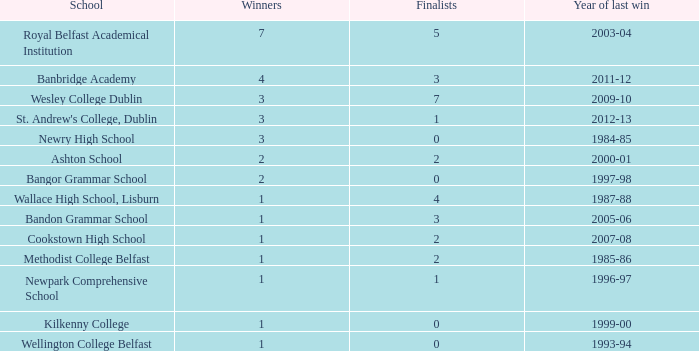Which educational institution experienced its latest success in the 2007-08 school year? Cookstown High School. 